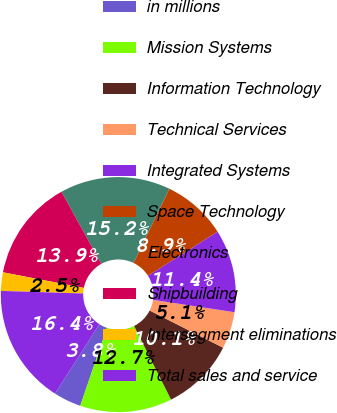Convert chart to OTSL. <chart><loc_0><loc_0><loc_500><loc_500><pie_chart><fcel>in millions<fcel>Mission Systems<fcel>Information Technology<fcel>Technical Services<fcel>Integrated Systems<fcel>Space Technology<fcel>Electronics<fcel>Shipbuilding<fcel>Intersegment eliminations<fcel>Total sales and service<nl><fcel>3.8%<fcel>12.66%<fcel>10.13%<fcel>5.07%<fcel>11.39%<fcel>8.86%<fcel>15.19%<fcel>13.92%<fcel>2.54%<fcel>16.45%<nl></chart> 